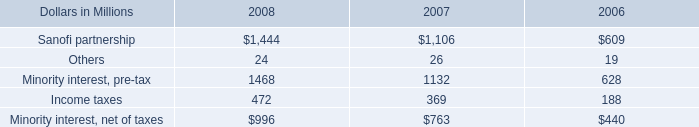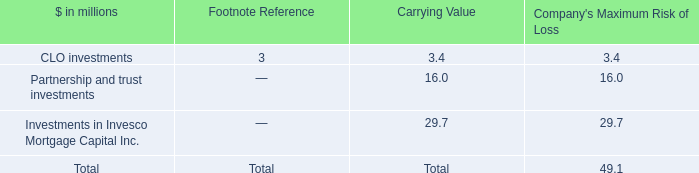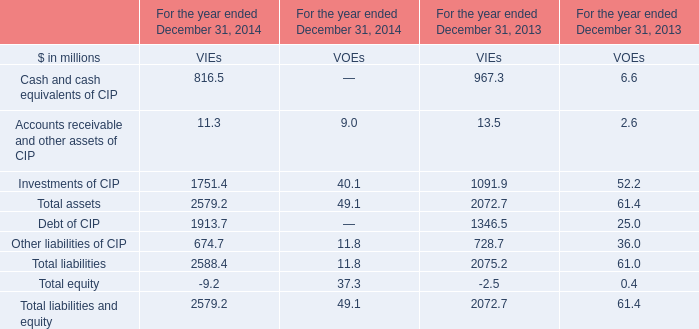What is the sum of the Accounts receivable and other assets of CIP in the years for VIEs where Accounts receivable and other assets of CIP is positive? (in million) 
Computations: (11.3 + 13.5)
Answer: 24.8. 